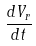<formula> <loc_0><loc_0><loc_500><loc_500>\frac { d V _ { r } } { d t }</formula> 